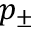Convert formula to latex. <formula><loc_0><loc_0><loc_500><loc_500>p _ { \pm }</formula> 